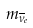<formula> <loc_0><loc_0><loc_500><loc_500>m _ { { \overline { \nu } } _ { e } }</formula> 